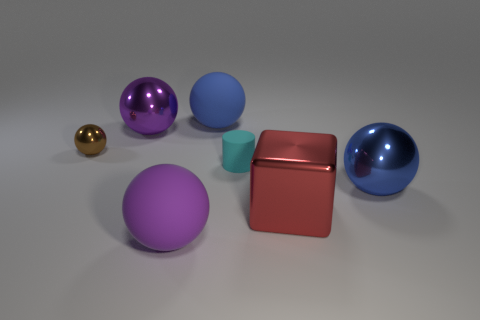Are there any other things that have the same material as the large cube?
Offer a terse response. Yes. What is the size of the purple metallic object that is the same shape as the brown shiny thing?
Your answer should be very brief. Large. Is the size of the blue sphere that is on the right side of the blue rubber ball the same as the large red metallic cube?
Offer a terse response. Yes. How many tiny yellow matte objects are there?
Make the answer very short. 0. What number of large spheres are behind the cube and in front of the large blue metal object?
Your answer should be compact. 0. Is there a tiny gray cylinder made of the same material as the large red object?
Offer a terse response. No. What is the material of the small object that is to the left of the big metallic sphere that is on the left side of the big shiny block?
Ensure brevity in your answer.  Metal. Are there an equal number of blue spheres on the left side of the brown metallic ball and tiny matte objects that are to the left of the big purple shiny ball?
Your answer should be compact. Yes. Does the big blue metal object have the same shape as the brown metal thing?
Provide a succinct answer. Yes. What is the large object that is right of the small cyan cylinder and behind the big red block made of?
Your answer should be very brief. Metal. 